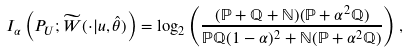Convert formula to latex. <formula><loc_0><loc_0><loc_500><loc_500>I _ { \alpha } \left ( P _ { U } ; \widetilde { W } ( \cdot | u , \hat { \theta } ) \right ) = \log _ { 2 } \left ( \frac { ( \mathbb { P } + \mathbb { Q } + \mathbb { N } ) ( \mathbb { P } + \alpha ^ { 2 } \mathbb { Q } ) } { \mathbb { P } \mathbb { Q } ( 1 - \alpha ) ^ { 2 } + \mathbb { N } ( \mathbb { P } + \alpha ^ { 2 } \mathbb { Q } ) } \right ) ,</formula> 